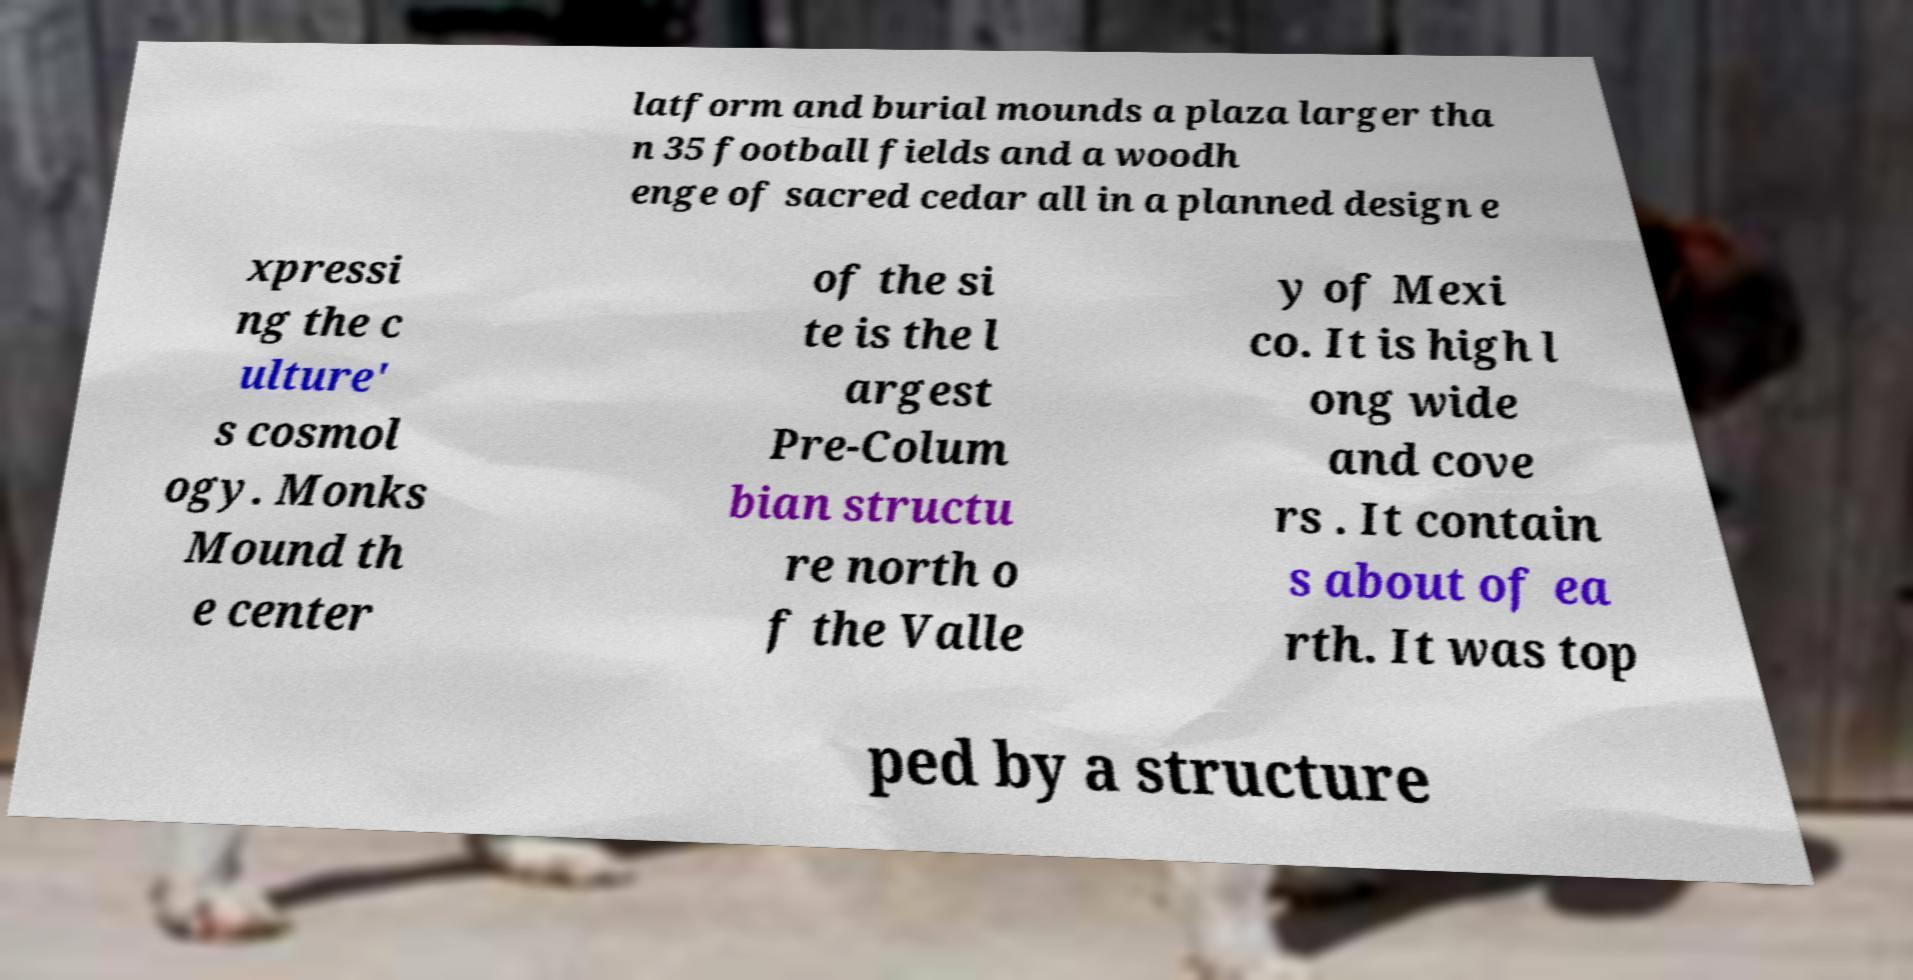Can you read and provide the text displayed in the image?This photo seems to have some interesting text. Can you extract and type it out for me? latform and burial mounds a plaza larger tha n 35 football fields and a woodh enge of sacred cedar all in a planned design e xpressi ng the c ulture' s cosmol ogy. Monks Mound th e center of the si te is the l argest Pre-Colum bian structu re north o f the Valle y of Mexi co. It is high l ong wide and cove rs . It contain s about of ea rth. It was top ped by a structure 